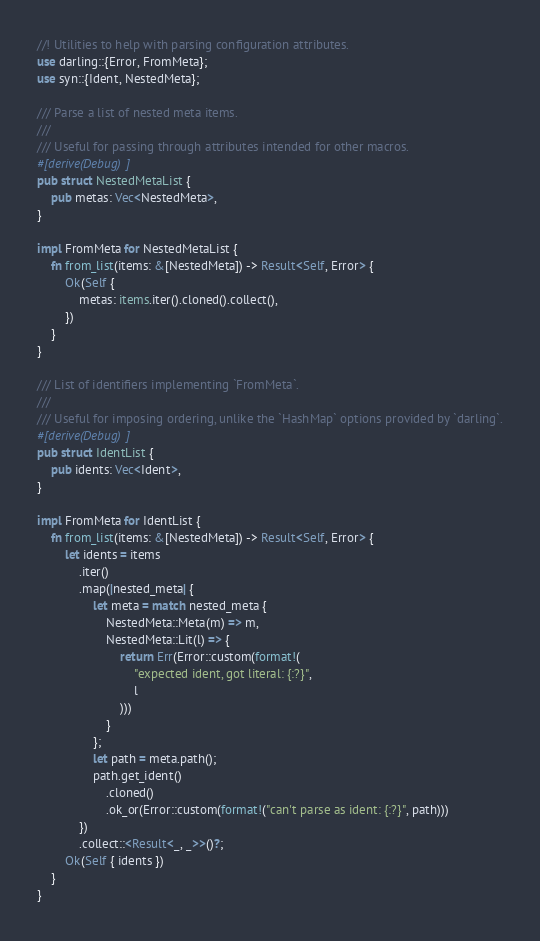<code> <loc_0><loc_0><loc_500><loc_500><_Rust_>//! Utilities to help with parsing configuration attributes.
use darling::{Error, FromMeta};
use syn::{Ident, NestedMeta};

/// Parse a list of nested meta items.
///
/// Useful for passing through attributes intended for other macros.
#[derive(Debug)]
pub struct NestedMetaList {
    pub metas: Vec<NestedMeta>,
}

impl FromMeta for NestedMetaList {
    fn from_list(items: &[NestedMeta]) -> Result<Self, Error> {
        Ok(Self {
            metas: items.iter().cloned().collect(),
        })
    }
}

/// List of identifiers implementing `FromMeta`.
///
/// Useful for imposing ordering, unlike the `HashMap` options provided by `darling`.
#[derive(Debug)]
pub struct IdentList {
    pub idents: Vec<Ident>,
}

impl FromMeta for IdentList {
    fn from_list(items: &[NestedMeta]) -> Result<Self, Error> {
        let idents = items
            .iter()
            .map(|nested_meta| {
                let meta = match nested_meta {
                    NestedMeta::Meta(m) => m,
                    NestedMeta::Lit(l) => {
                        return Err(Error::custom(format!(
                            "expected ident, got literal: {:?}",
                            l
                        )))
                    }
                };
                let path = meta.path();
                path.get_ident()
                    .cloned()
                    .ok_or(Error::custom(format!("can't parse as ident: {:?}", path)))
            })
            .collect::<Result<_, _>>()?;
        Ok(Self { idents })
    }
}
</code> 